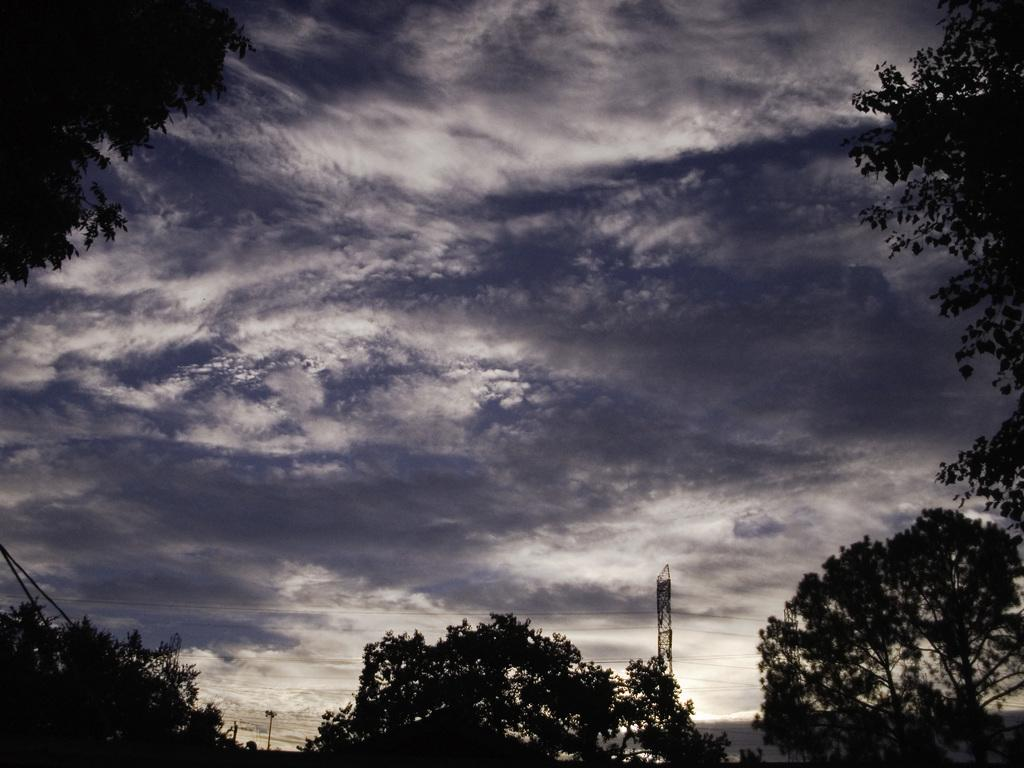What type of vegetation can be seen in the image? There are trees in the image. What structures are present in the image? There are poles and a tower in the image. What is connected between the poles in the image? There are wires connected between the poles in the image. What is visible in the background of the image? The sky is visible in the image, and it has white and blue colors. How many chairs are placed around the bread in the image? There are no chairs or bread present in the image. What type of flight is depicted in the image? There is no flight depicted in the image; it features trees, poles, a tower, and wires. 